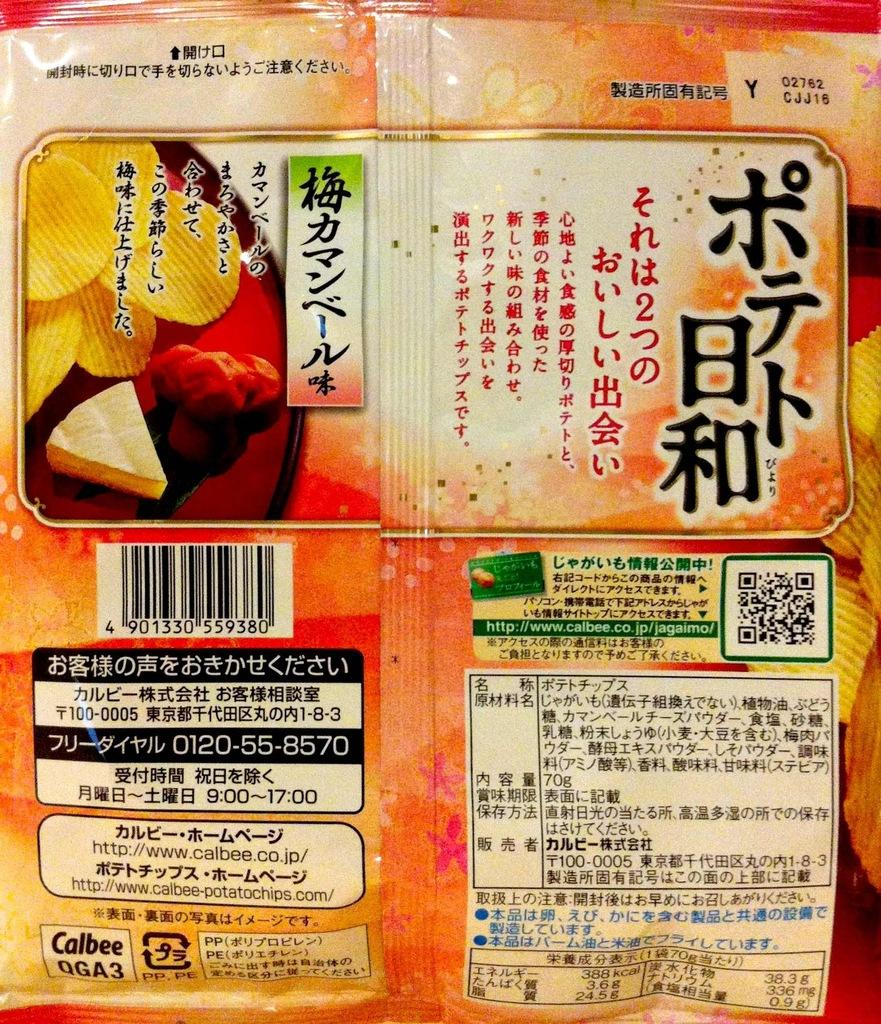What is the main subject in the center of the image? There is a cover in the center of the image. What type of arch can be seen supporting the cover in the image? There is no arch present in the image; it only features a cover. How many buns are visible underneath the cover in the image? There is no mention of buns in the image; only a cover is present. 